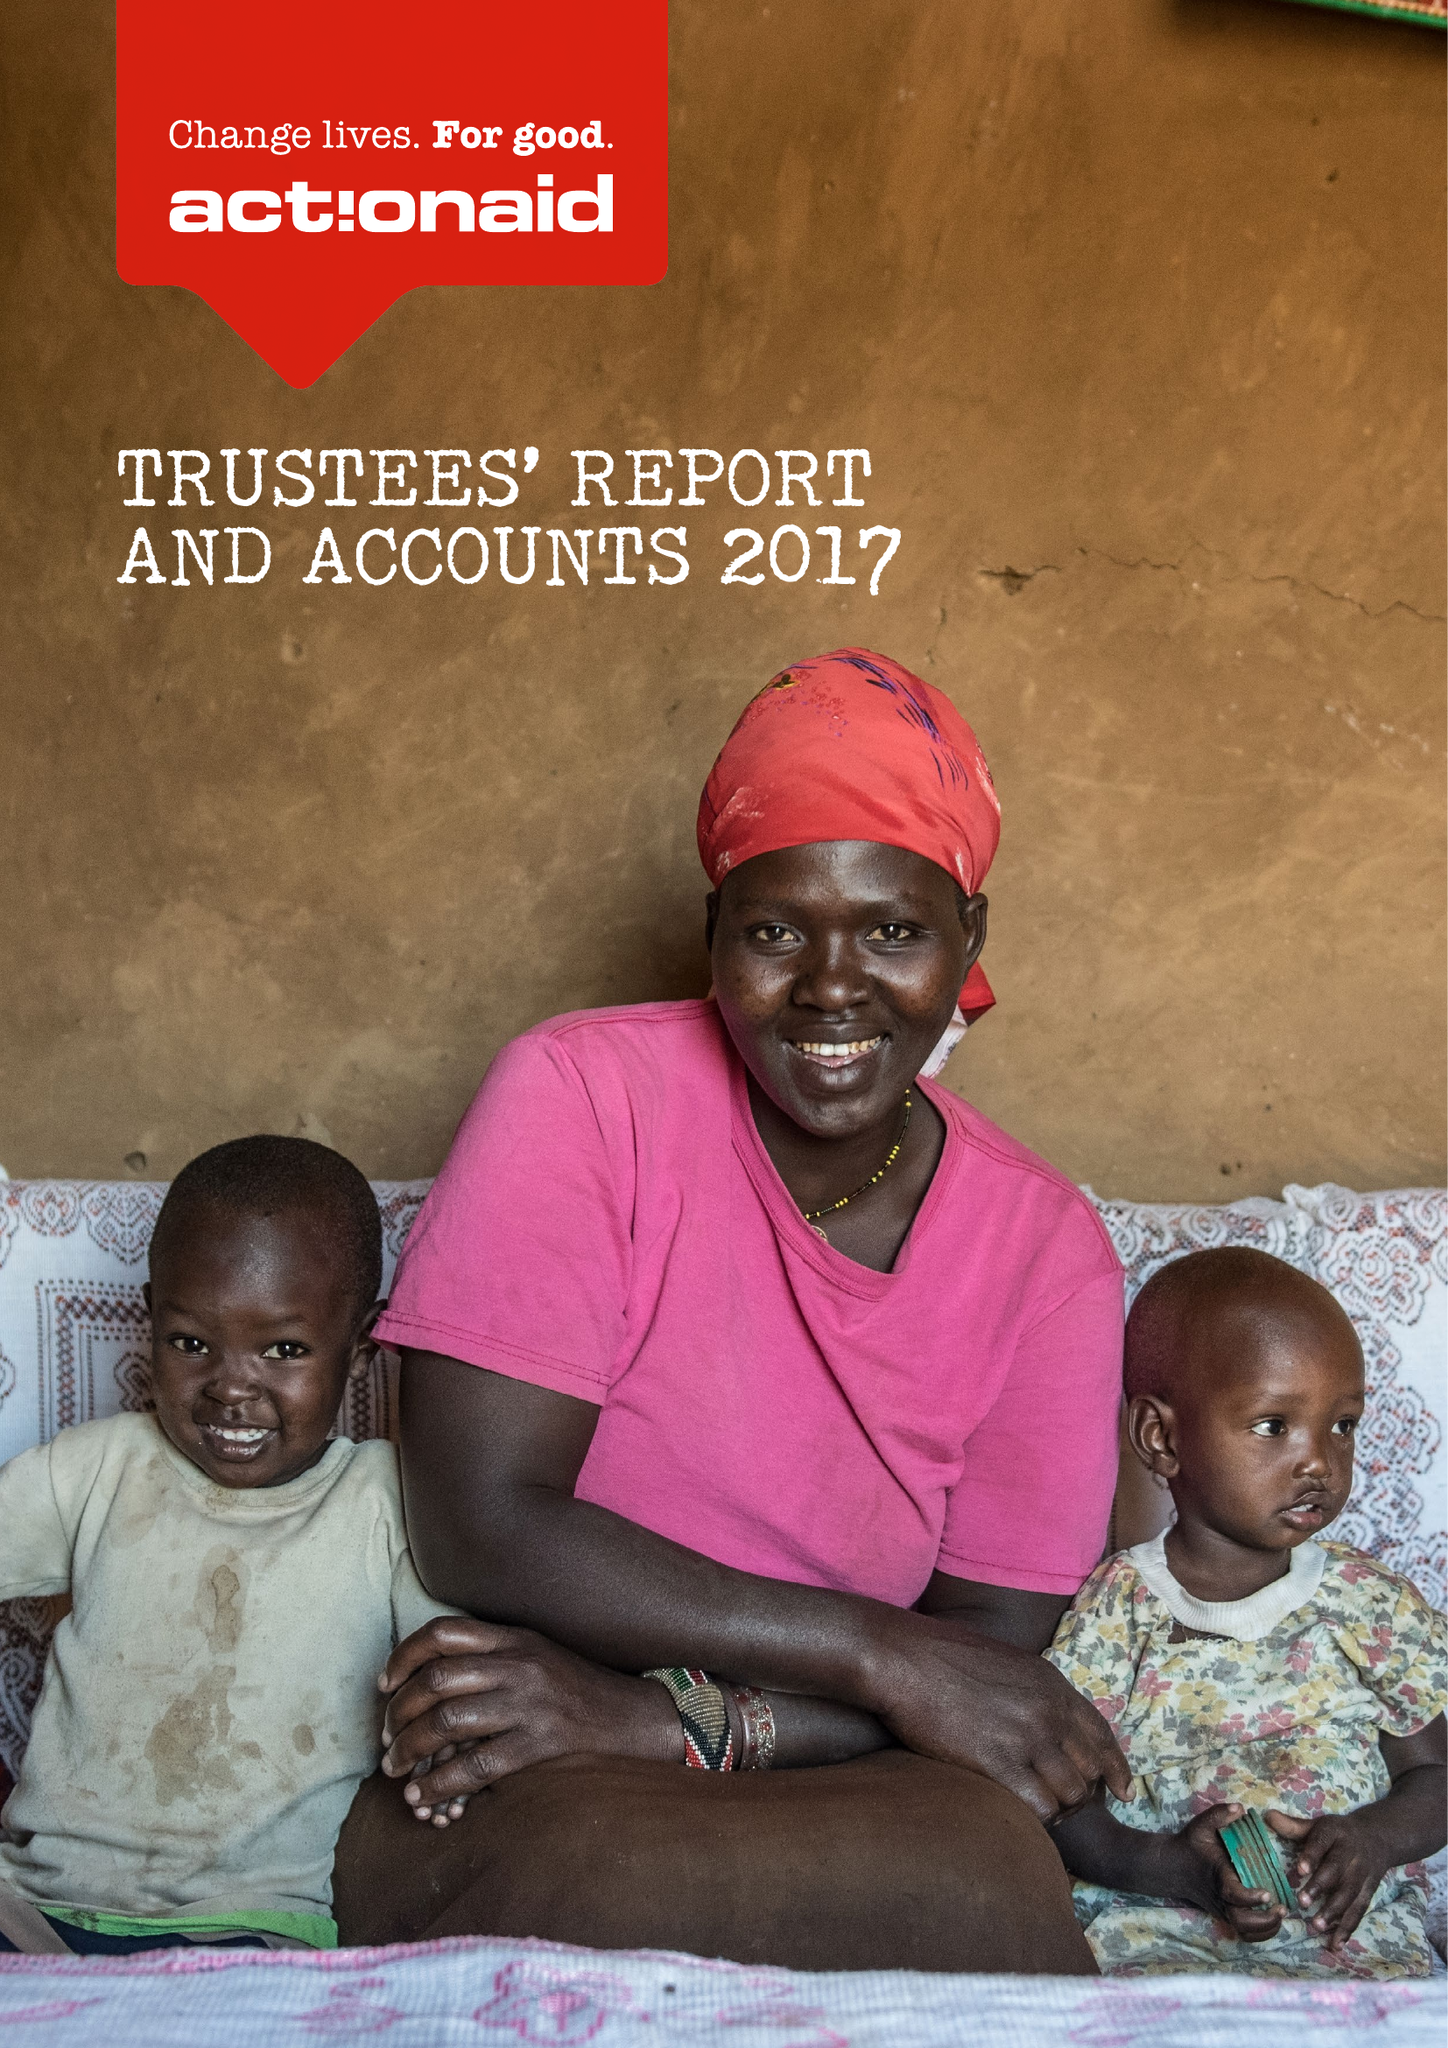What is the value for the report_date?
Answer the question using a single word or phrase. 2017-12-31 